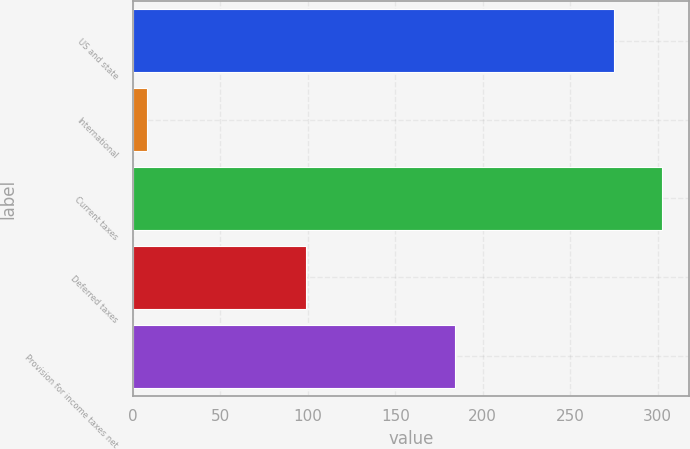Convert chart. <chart><loc_0><loc_0><loc_500><loc_500><bar_chart><fcel>US and state<fcel>International<fcel>Current taxes<fcel>Deferred taxes<fcel>Provision for income taxes net<nl><fcel>275<fcel>8<fcel>302.5<fcel>99<fcel>184<nl></chart> 